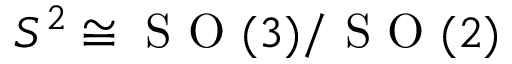Convert formula to latex. <formula><loc_0><loc_0><loc_500><loc_500>S ^ { 2 } \cong S O ( 3 ) / S O ( 2 )</formula> 